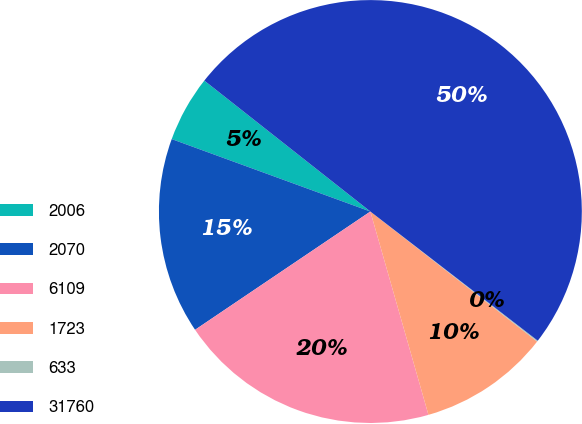Convert chart. <chart><loc_0><loc_0><loc_500><loc_500><pie_chart><fcel>2006<fcel>2070<fcel>6109<fcel>1723<fcel>633<fcel>31760<nl><fcel>5.06%<fcel>15.01%<fcel>19.98%<fcel>10.03%<fcel>0.08%<fcel>49.83%<nl></chart> 